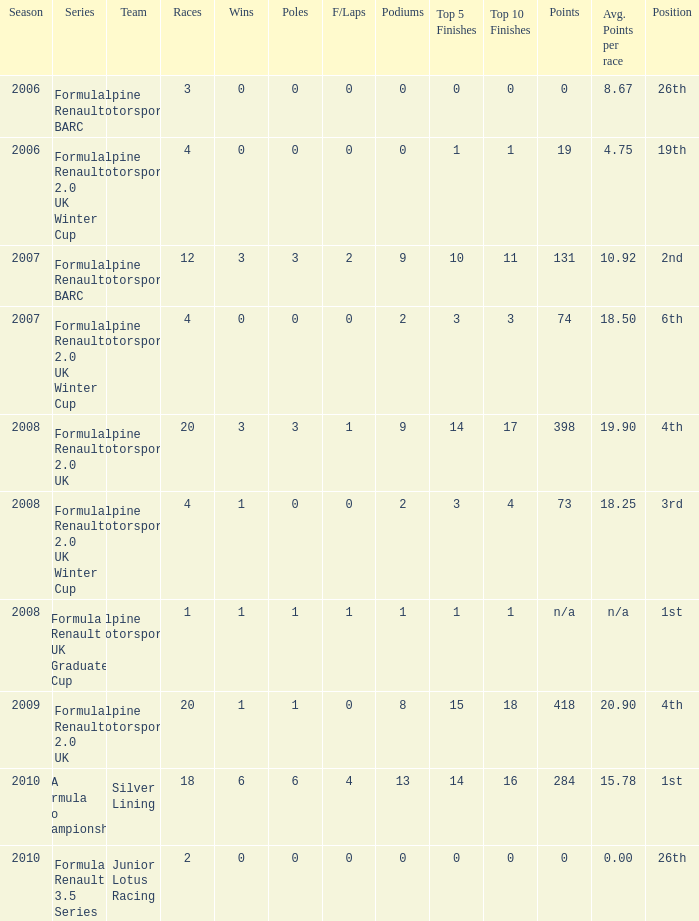What races achieved 0 f/laps and 1 pole position? 20.0. 